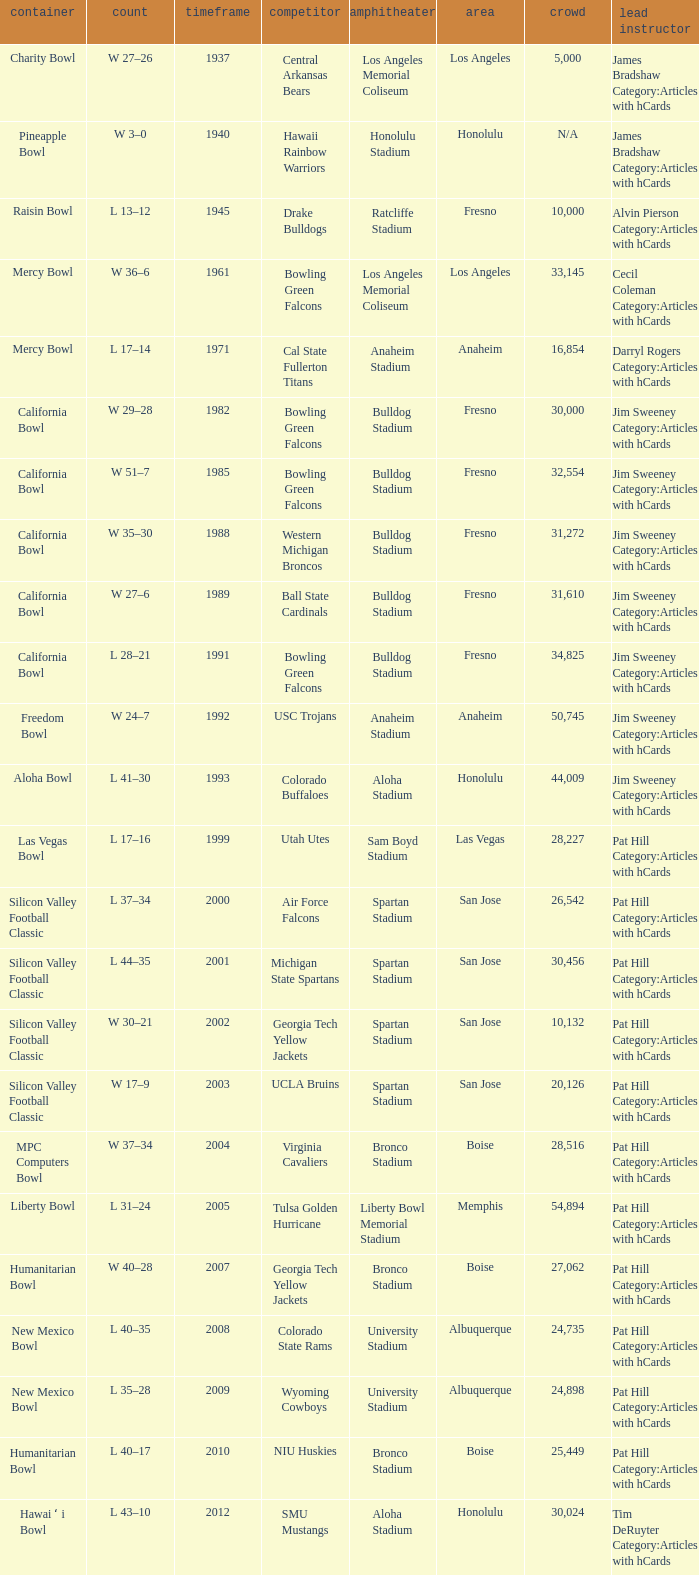Where was the California bowl played with 30,000 attending? Fresno. 